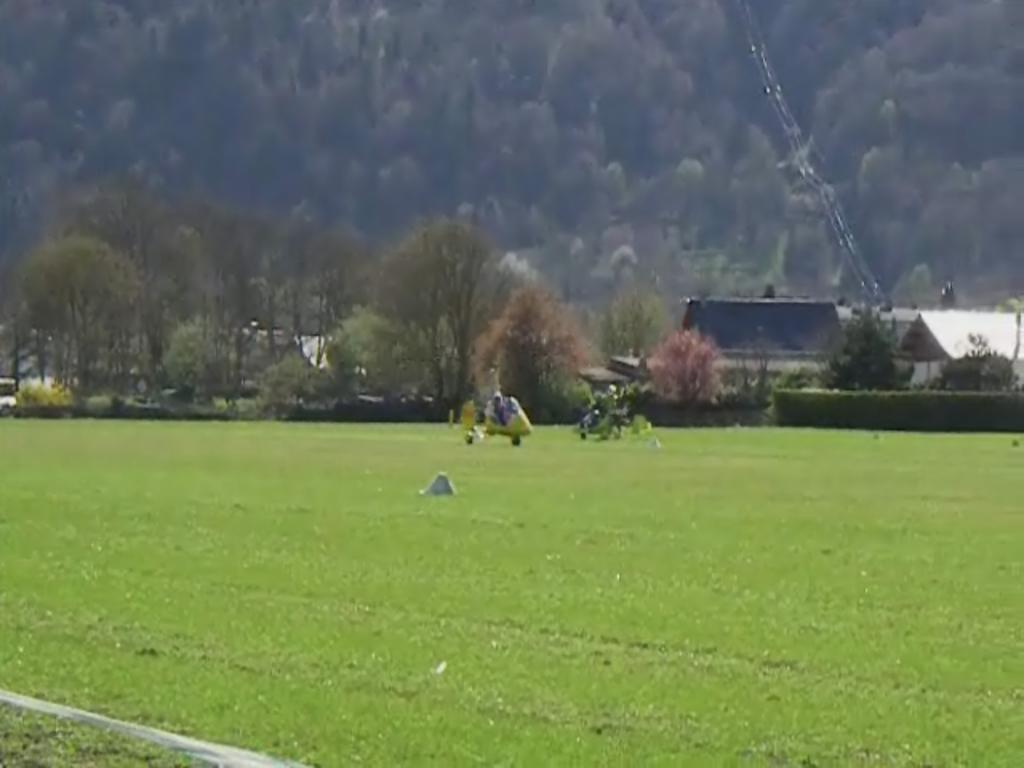What is happening on the grass in the image? There are vehicles on the grass in the image, and people are seated in the vehicles. What can be seen in the background of the image? There are trees and houses in the background of the image. What riddle is being solved by the children in the image? There are no children present in the image, and no riddle is being solved. What historical event is depicted in the image? The image does not depict any historical event; it shows vehicles on the grass with people seated in them. 